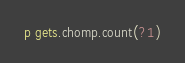<code> <loc_0><loc_0><loc_500><loc_500><_Ruby_>p gets.chomp.count(?1)</code> 